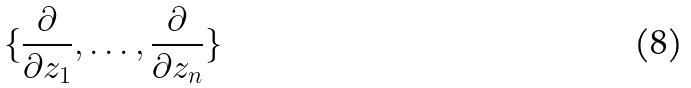Convert formula to latex. <formula><loc_0><loc_0><loc_500><loc_500>\{ \frac { \partial } { \partial z _ { 1 } } , \dots , \frac { \partial } { \partial z _ { n } } \}</formula> 